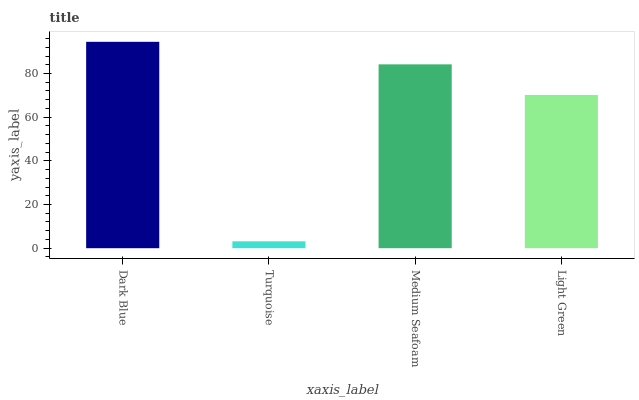Is Turquoise the minimum?
Answer yes or no. Yes. Is Dark Blue the maximum?
Answer yes or no. Yes. Is Medium Seafoam the minimum?
Answer yes or no. No. Is Medium Seafoam the maximum?
Answer yes or no. No. Is Medium Seafoam greater than Turquoise?
Answer yes or no. Yes. Is Turquoise less than Medium Seafoam?
Answer yes or no. Yes. Is Turquoise greater than Medium Seafoam?
Answer yes or no. No. Is Medium Seafoam less than Turquoise?
Answer yes or no. No. Is Medium Seafoam the high median?
Answer yes or no. Yes. Is Light Green the low median?
Answer yes or no. Yes. Is Light Green the high median?
Answer yes or no. No. Is Medium Seafoam the low median?
Answer yes or no. No. 